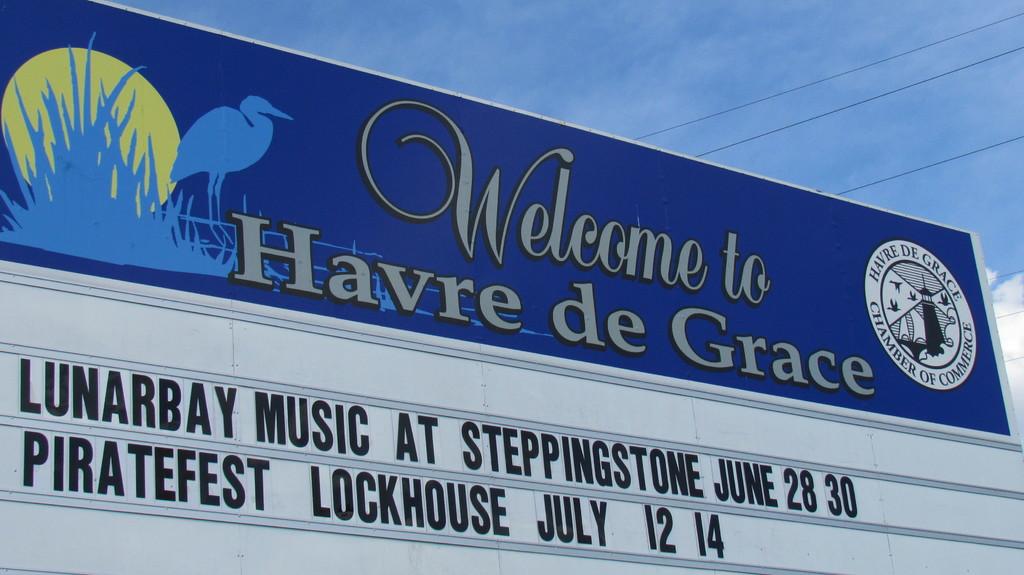What event is on july 12 and 14th?
Make the answer very short. Piratefest lockhouse. What is the name of this place?
Your response must be concise. Havre de grace. 